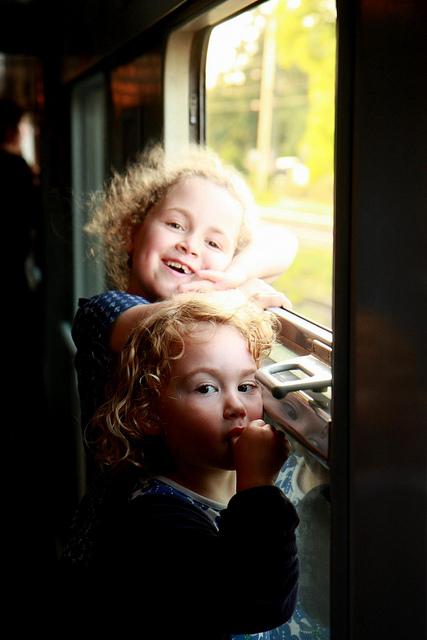What color is this kids shirt?
Write a very short answer. Blue. Where are the girls?
Give a very brief answer. Train. What color is the kids hair?
Be succinct. Blonde. Are both children looking out of the window?
Give a very brief answer. No. Which child is not blurred by the camera lens?
Give a very brief answer. Front. How many windows are on the train?
Be succinct. 1. Are both kids sucking their thumbs?
Short answer required. No. 